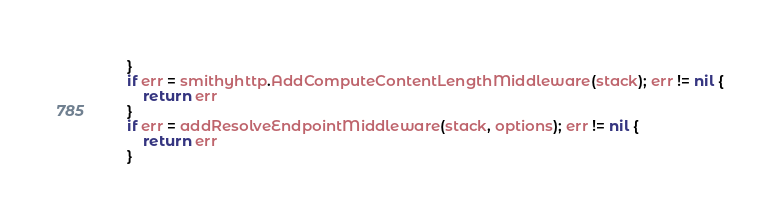Convert code to text. <code><loc_0><loc_0><loc_500><loc_500><_Go_>	}
	if err = smithyhttp.AddComputeContentLengthMiddleware(stack); err != nil {
		return err
	}
	if err = addResolveEndpointMiddleware(stack, options); err != nil {
		return err
	}</code> 